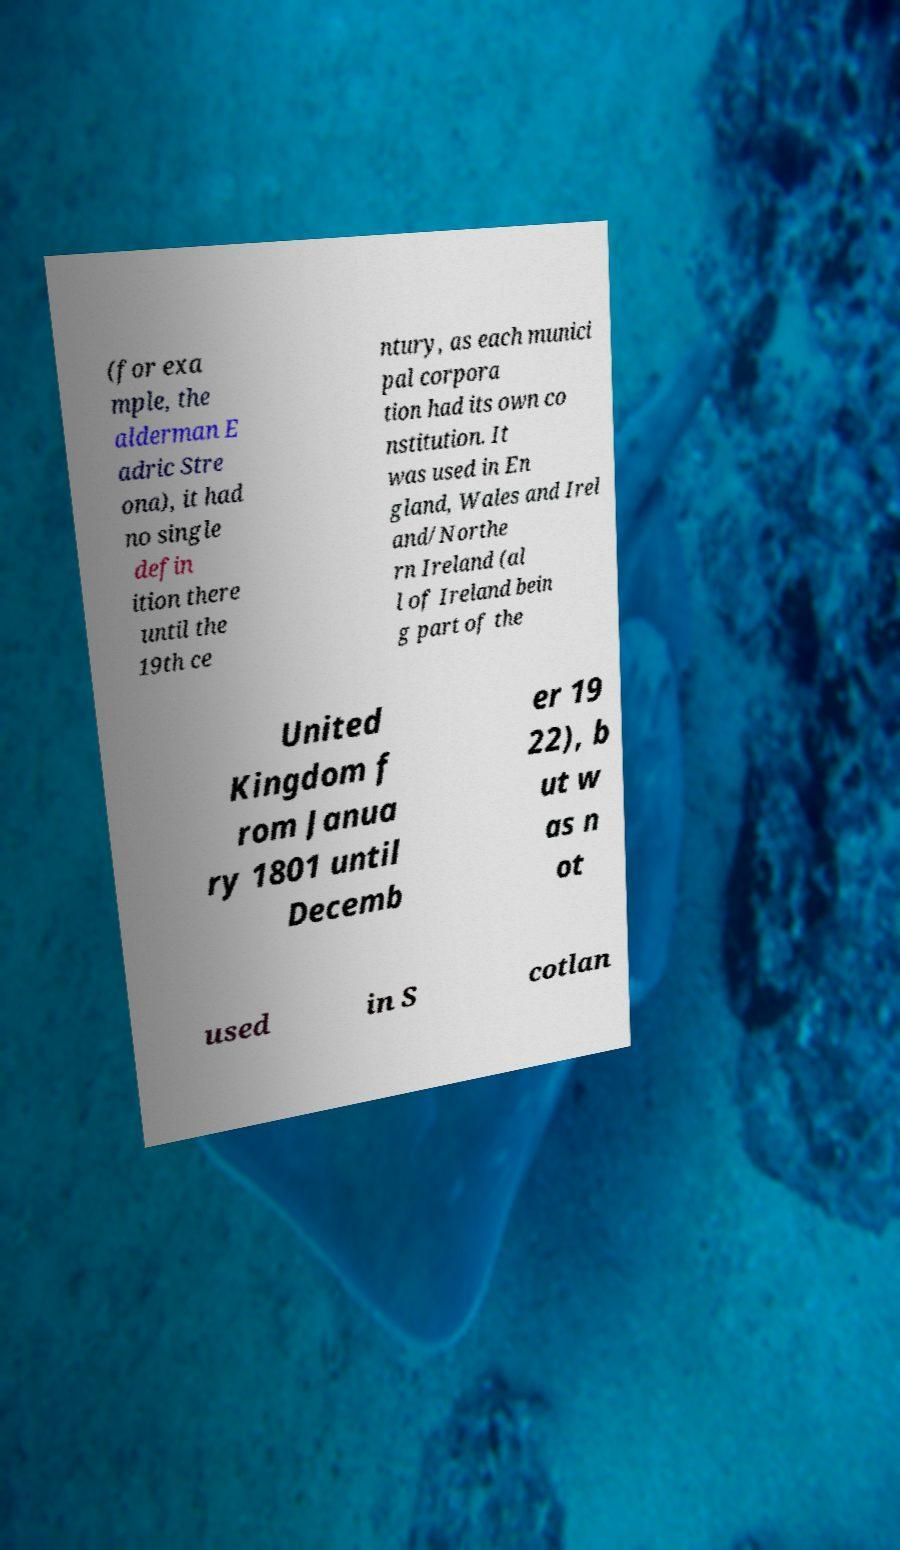Can you accurately transcribe the text from the provided image for me? (for exa mple, the alderman E adric Stre ona), it had no single defin ition there until the 19th ce ntury, as each munici pal corpora tion had its own co nstitution. It was used in En gland, Wales and Irel and/Northe rn Ireland (al l of Ireland bein g part of the United Kingdom f rom Janua ry 1801 until Decemb er 19 22), b ut w as n ot used in S cotlan 